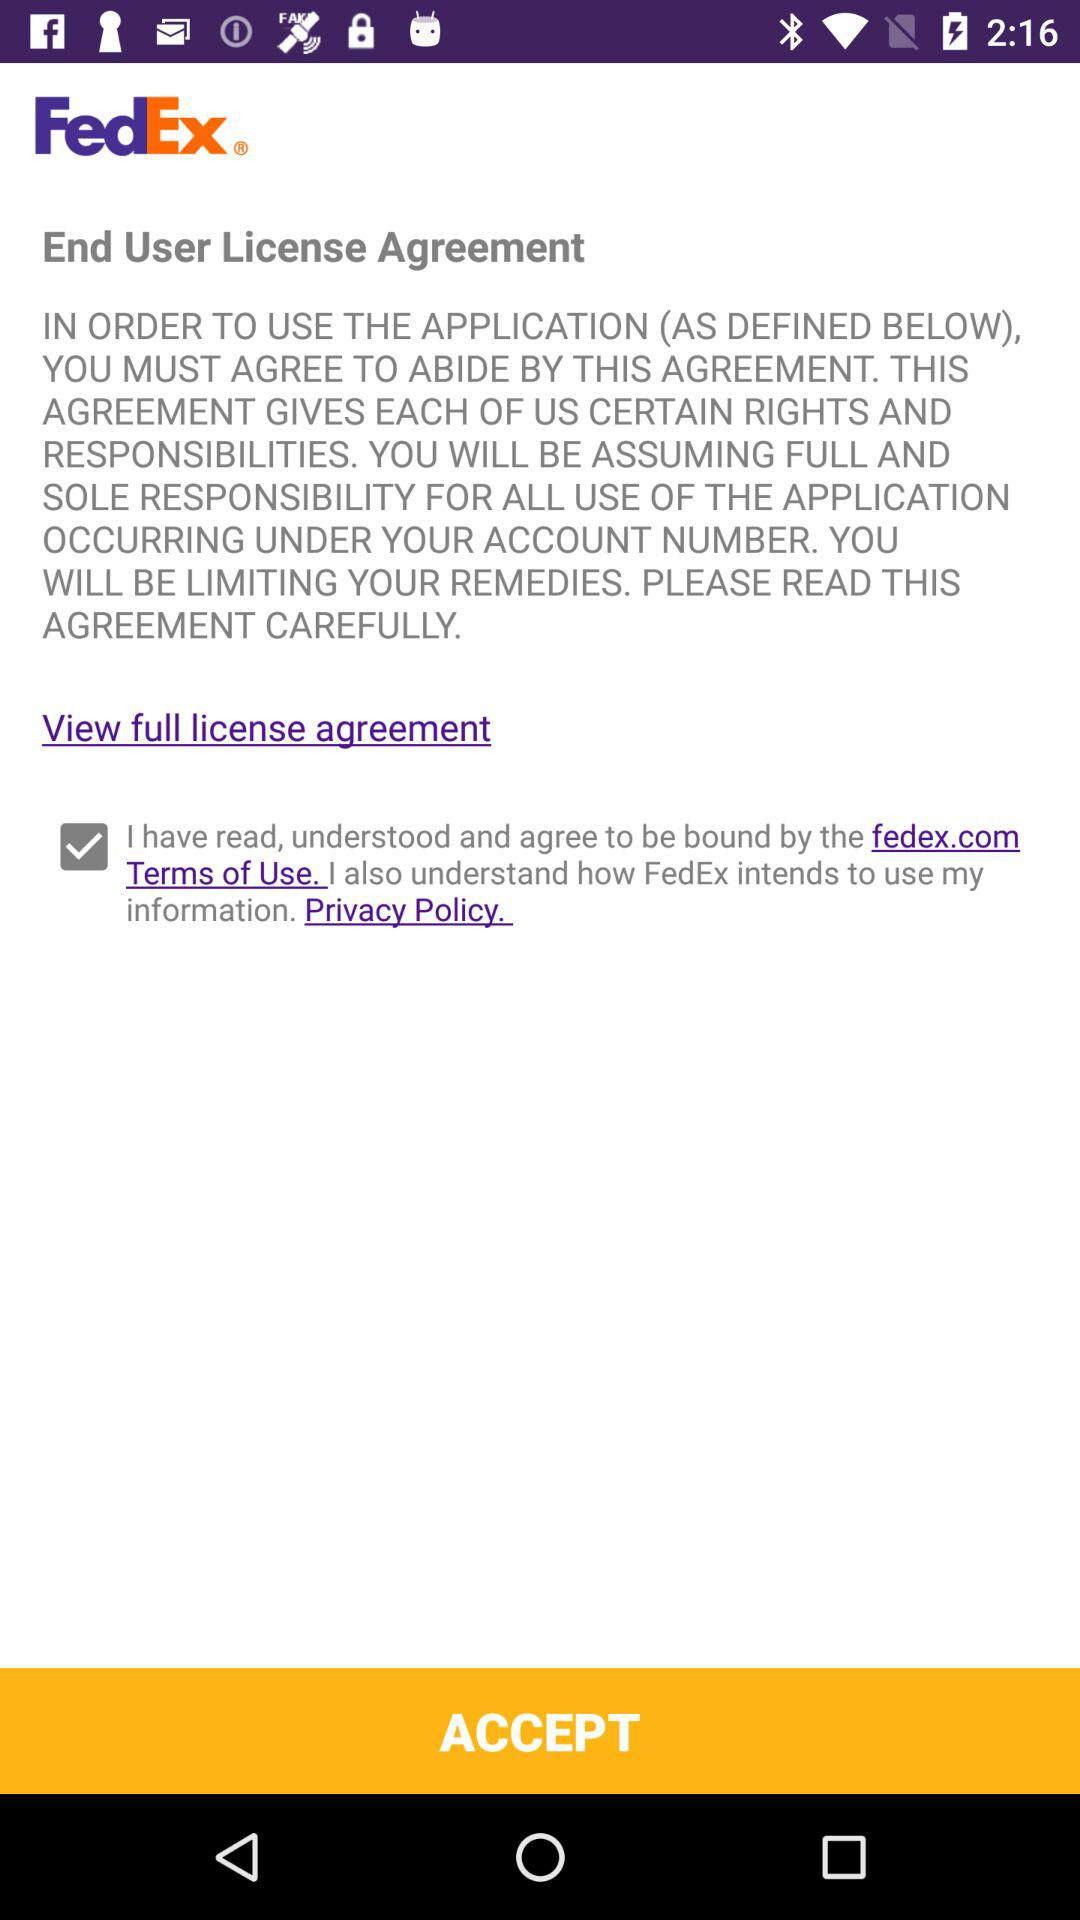How many check boxes are there on the screen?
Answer the question using a single word or phrase. 1 